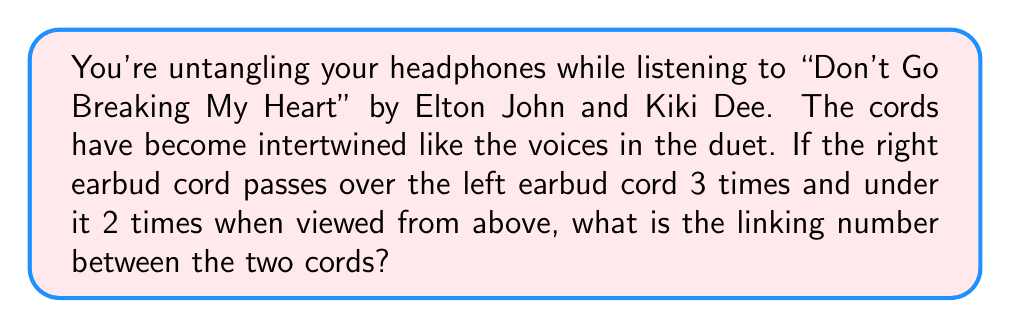Solve this math problem. Let's approach this step-by-step:

1) In Knot Theory, the linking number is a numerical invariant that describes how two closed curves are linked in three-dimensional space.

2) The formula for the linking number is:

   $$Lk = \frac{1}{2} \sum_{i} \epsilon_i$$

   where $\epsilon_i$ is the sign of each crossing (+1 for right-handed and -1 for left-handed).

3) In this case, we're viewing the cords from above. When the right cord passes over the left, it's a positive crossing (+1). When it passes under, it's a negative crossing (-1).

4) We have:
   - 3 positive crossings: $3 \times (+1) = +3$
   - 2 negative crossings: $2 \times (-1) = -2$

5) Sum of all crossings: $3 + (-2) = 1$

6) Applying the formula:

   $$Lk = \frac{1}{2} \times 1 = \frac{1}{2}$$

Therefore, the linking number between the two headphone cords is $\frac{1}{2}$.
Answer: $\frac{1}{2}$ 